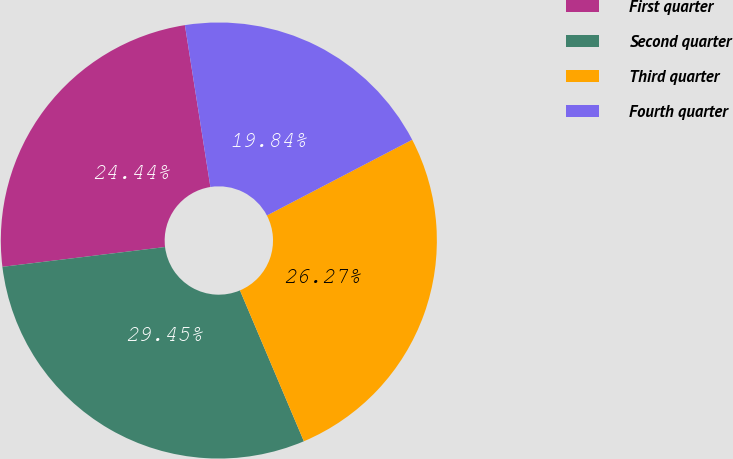<chart> <loc_0><loc_0><loc_500><loc_500><pie_chart><fcel>First quarter<fcel>Second quarter<fcel>Third quarter<fcel>Fourth quarter<nl><fcel>24.44%<fcel>29.45%<fcel>26.27%<fcel>19.84%<nl></chart> 